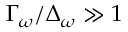Convert formula to latex. <formula><loc_0><loc_0><loc_500><loc_500>\Gamma _ { \omega } / \Delta _ { \omega } \gg 1</formula> 